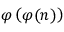<formula> <loc_0><loc_0><loc_500><loc_500>\varphi \left ( \varphi ( n ) \right )</formula> 